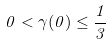Convert formula to latex. <formula><loc_0><loc_0><loc_500><loc_500>0 < \gamma ( 0 ) \leq \frac { 1 } { 3 }</formula> 